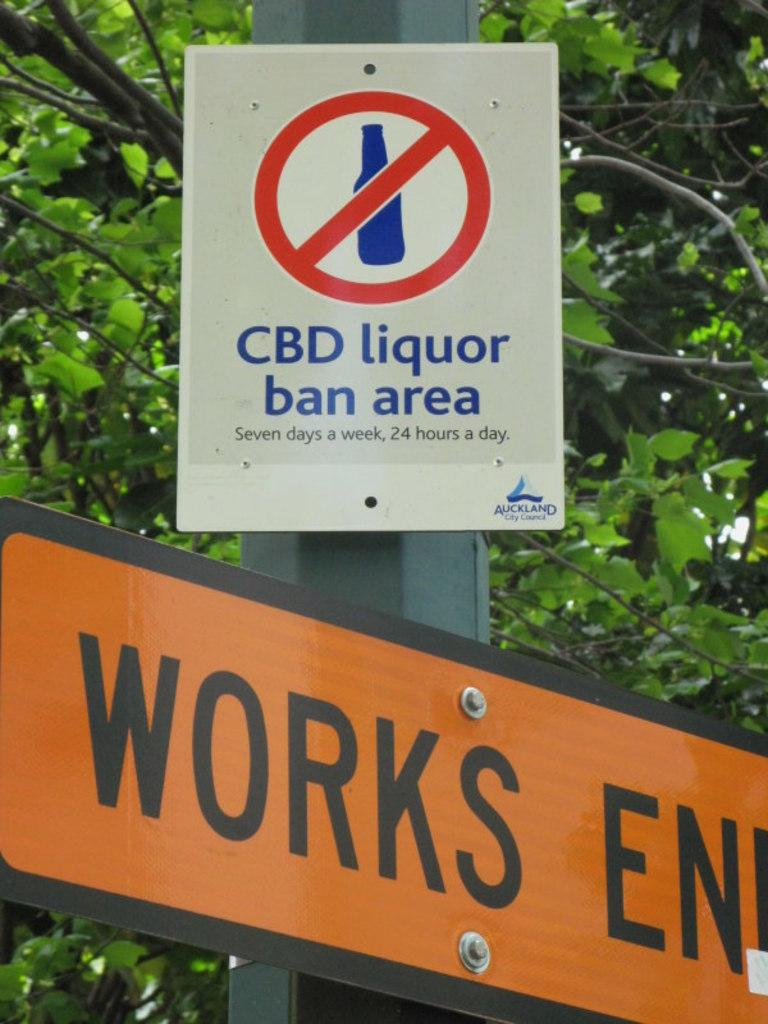<image>
Offer a succinct explanation of the picture presented. The street sign lets you know that you cannot have CBD liquor in the area. 